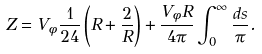Convert formula to latex. <formula><loc_0><loc_0><loc_500><loc_500>Z = V _ { \phi } \frac { 1 } { 2 4 } \left ( R + \frac { 2 } { R } \right ) + \frac { V _ { \phi } R } { 4 \pi } \int _ { 0 } ^ { \infty } \frac { d s } { \pi } .</formula> 